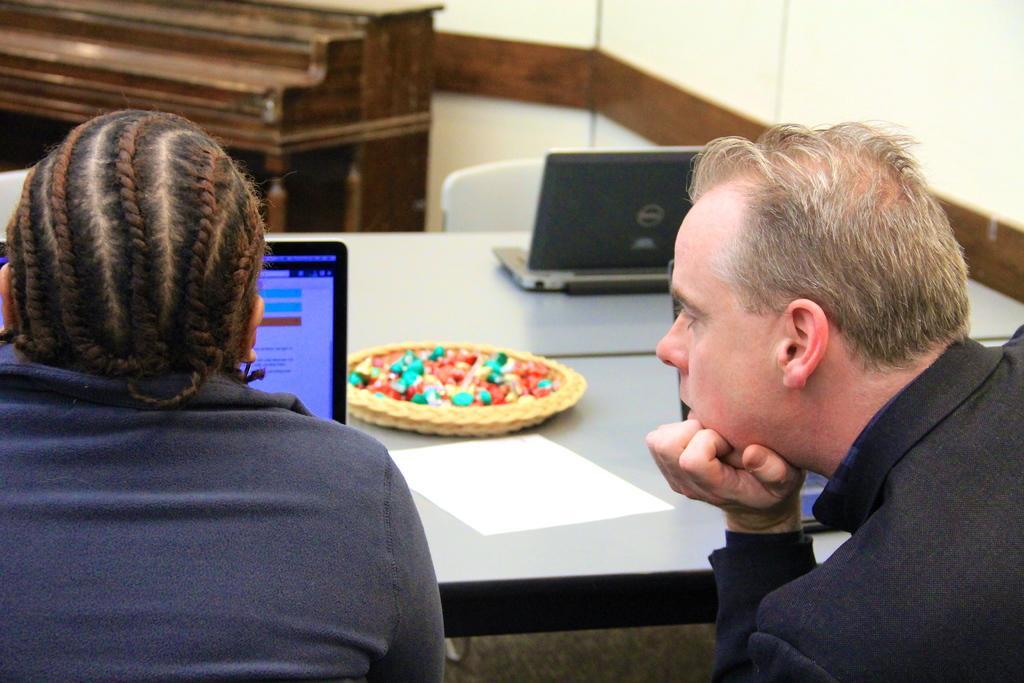Could you give a brief overview of what you see in this image? In the picture we can see a man and a woman sitting on the chair near the desk and on the desk, we can see a laptop and woman working on it and a man watching it and just behind the laptop we can see a plate and some stones in it which are colorful and behind it, we can see another laptop which is also gray in color and behind the desk we can see a desk made up of wood and near it we can see a chair which is white in color and behind it we can see a wall. 